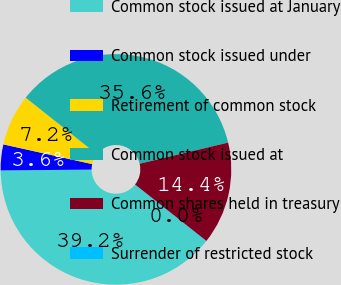Convert chart to OTSL. <chart><loc_0><loc_0><loc_500><loc_500><pie_chart><fcel>Common stock issued at January<fcel>Common stock issued under<fcel>Retirement of common stock<fcel>Common stock issued at<fcel>Common shares held in treasury<fcel>Surrender of restricted stock<nl><fcel>39.17%<fcel>3.62%<fcel>7.21%<fcel>35.58%<fcel>14.39%<fcel>0.03%<nl></chart> 